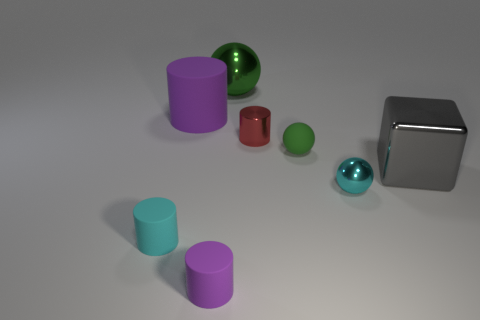Subtract all green balls. How many balls are left? 1 Subtract all yellow cubes. How many purple cylinders are left? 2 Add 1 tiny cyan balls. How many objects exist? 9 Subtract all cyan cylinders. How many cylinders are left? 3 Subtract all blocks. How many objects are left? 7 Add 7 metal cubes. How many metal cubes exist? 8 Subtract 0 brown blocks. How many objects are left? 8 Subtract all green cylinders. Subtract all yellow blocks. How many cylinders are left? 4 Subtract all cyan metal things. Subtract all tiny purple rubber things. How many objects are left? 6 Add 4 tiny metallic objects. How many tiny metallic objects are left? 6 